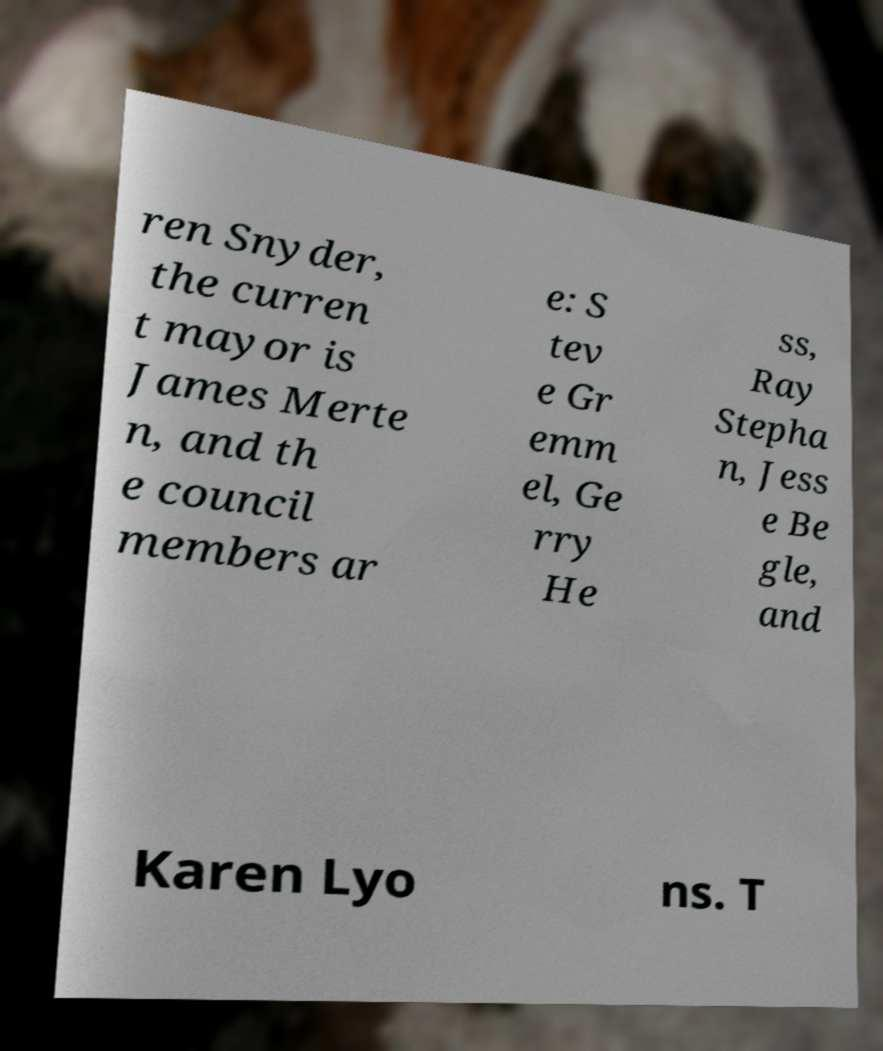Please read and relay the text visible in this image. What does it say? ren Snyder, the curren t mayor is James Merte n, and th e council members ar e: S tev e Gr emm el, Ge rry He ss, Ray Stepha n, Jess e Be gle, and Karen Lyo ns. T 